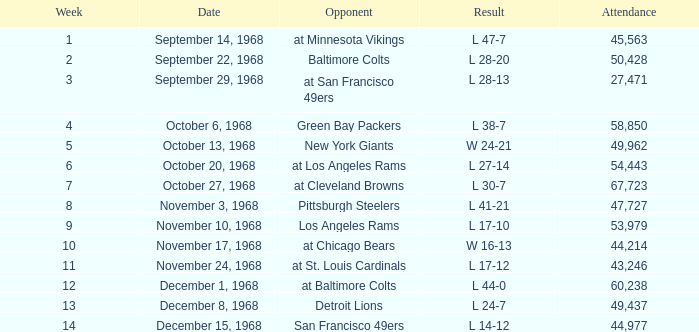Which Week has an Opponent of pittsburgh steelers, and an Attendance larger than 47,727? None. 